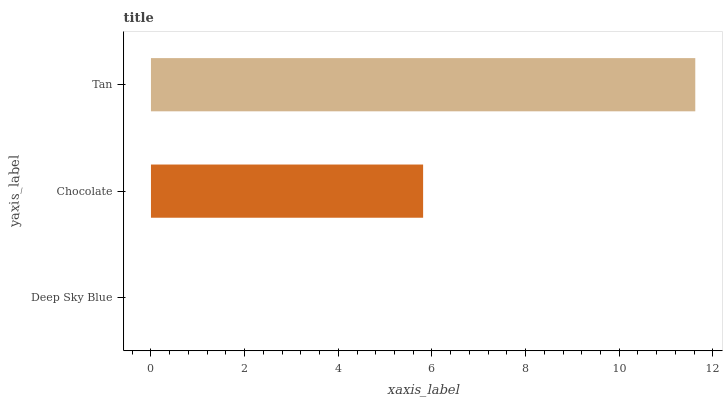Is Deep Sky Blue the minimum?
Answer yes or no. Yes. Is Tan the maximum?
Answer yes or no. Yes. Is Chocolate the minimum?
Answer yes or no. No. Is Chocolate the maximum?
Answer yes or no. No. Is Chocolate greater than Deep Sky Blue?
Answer yes or no. Yes. Is Deep Sky Blue less than Chocolate?
Answer yes or no. Yes. Is Deep Sky Blue greater than Chocolate?
Answer yes or no. No. Is Chocolate less than Deep Sky Blue?
Answer yes or no. No. Is Chocolate the high median?
Answer yes or no. Yes. Is Chocolate the low median?
Answer yes or no. Yes. Is Deep Sky Blue the high median?
Answer yes or no. No. Is Deep Sky Blue the low median?
Answer yes or no. No. 